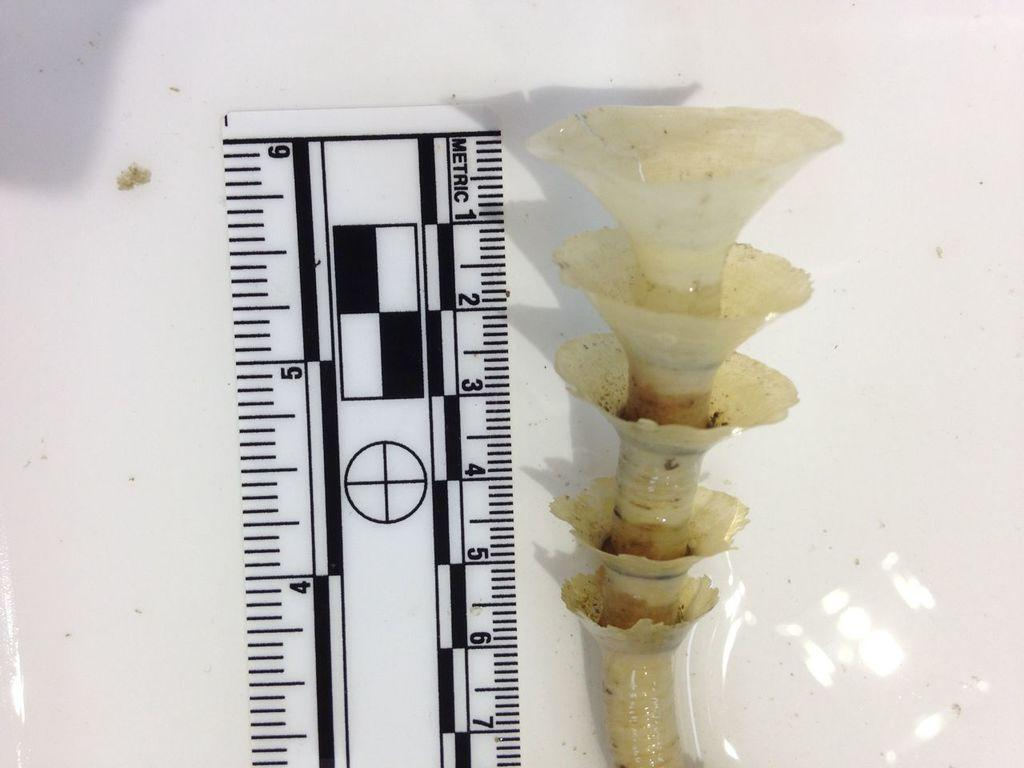<image>
Offer a succinct explanation of the picture presented. A clear metric ruler with numbers 1 through 7 displayed 